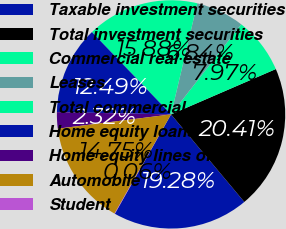<chart> <loc_0><loc_0><loc_500><loc_500><pie_chart><fcel>Taxable investment securities<fcel>Total investment securities<fcel>Commercial real estate<fcel>Leases<fcel>Total commercial<fcel>Home equity loans<fcel>Home equity lines of credit<fcel>Automobile<fcel>Student<nl><fcel>19.28%<fcel>20.41%<fcel>7.97%<fcel>6.84%<fcel>15.88%<fcel>12.49%<fcel>2.32%<fcel>14.75%<fcel>0.06%<nl></chart> 